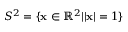<formula> <loc_0><loc_0><loc_500><loc_500>S ^ { 2 } = \{ { x } \in \mathbb { R } ^ { 2 } | | { x } | = 1 \}</formula> 